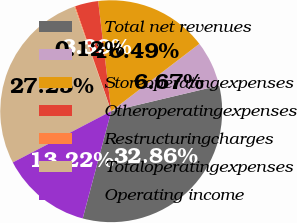Convert chart to OTSL. <chart><loc_0><loc_0><loc_500><loc_500><pie_chart><fcel>Total net revenues<fcel>Unnamed: 1<fcel>Storeoperatingexpenses<fcel>Otheroperatingexpenses<fcel>Restructuringcharges<fcel>Totaloperatingexpenses<fcel>Operating income<nl><fcel>32.86%<fcel>6.67%<fcel>16.49%<fcel>3.39%<fcel>0.12%<fcel>27.25%<fcel>13.22%<nl></chart> 